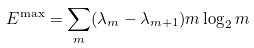<formula> <loc_0><loc_0><loc_500><loc_500>E ^ { \max } = \sum _ { m } ( \lambda _ { m } - \lambda _ { m + 1 } ) m \log _ { 2 } m</formula> 